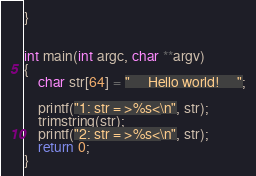<code> <loc_0><loc_0><loc_500><loc_500><_C_>}


int main(int argc, char **argv)
{
	char str[64] = "     Hello world!     ";

	printf("1: str = >%s<\n", str);
	trimstring(str);
	printf("2: str = >%s<\n", str);
	return 0;
}
</code> 